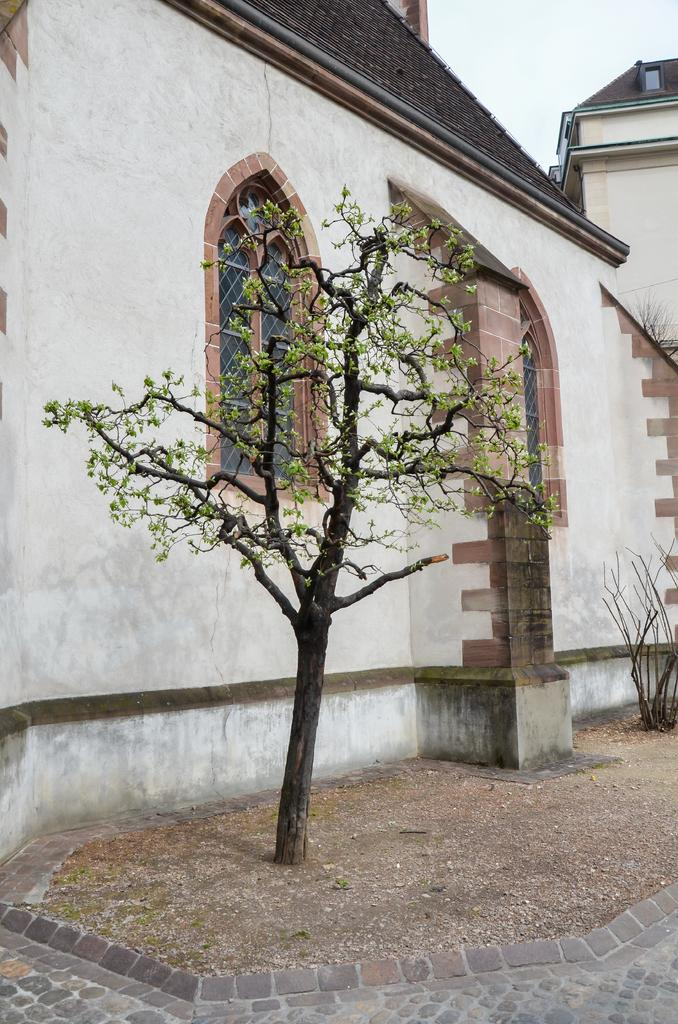What type of structures can be seen in the image? There are buildings in the image. What feature is visible on the buildings? There are windows visible in the image. What type of vegetation is present in the image? There is a tree and plants in the image. What part of the natural environment is visible in the image? The sky is visible in the image. What songs are being sung by the plants in the image? There are no songs being sung by the plants in the image, as plants do not have the ability to sing. 